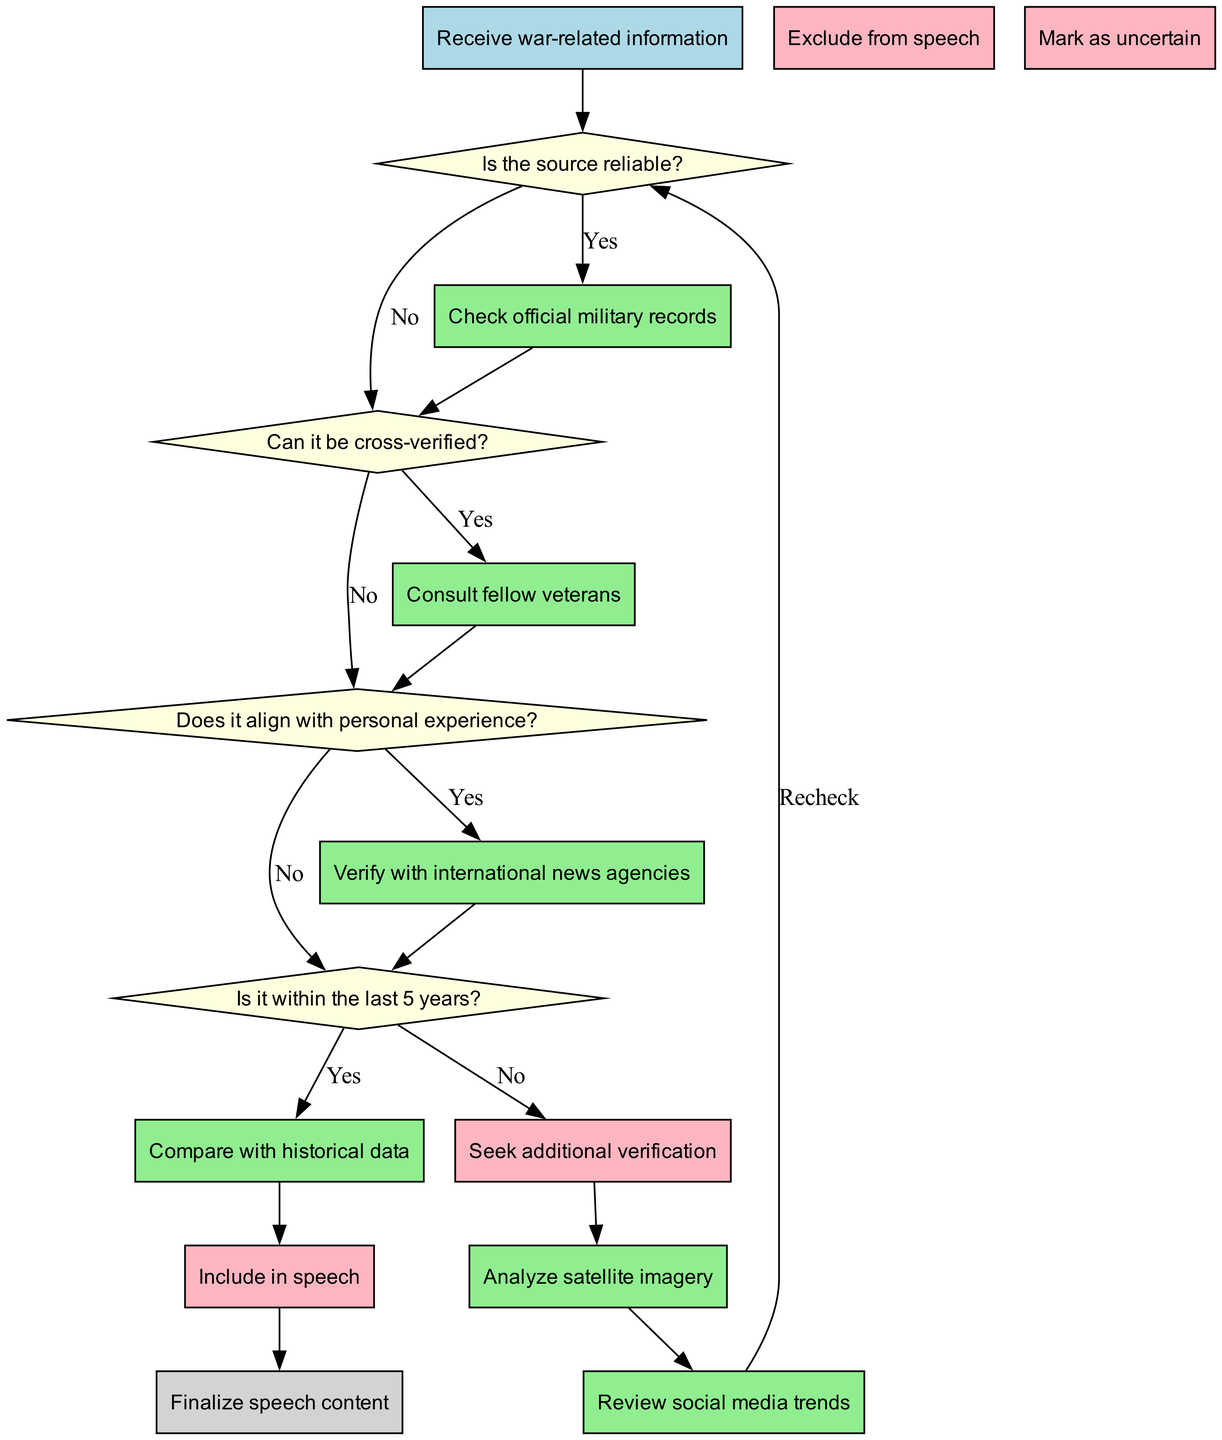What's the starting point of the flowchart? The flowchart begins with the node labeled "Receive war-related information," indicating the initial step in the process of verifying information.
Answer: Receive war-related information How many decision nodes are in the flowchart? There are four decision nodes in the flowchart, each representing a question regarding the reliability and relatability of the information.
Answer: 4 What happens if the source of the information is not reliable? If the source is not reliable, the flowchart directs the process to the next decision node, which asks if the information can be cross-verified.
Answer: Proceed to "Can it be cross-verified?" What is the first process to check if the source is reliable? The first process after confirming that the source is reliable is to "Check official military records."
Answer: Check official military records If the information can be cross-verified, which action can be taken? If the information can be cross-verified, it leads to the action of "Include in speech," indicating that the information is deemed credible and confirmed.
Answer: Include in speech What is the last node in the flowchart? The last node in the flowchart is labeled "Finalize speech content," which indicates the conclusion of the process after verifying the information.
Answer: Finalize speech content If the information does not align with personal experience, what is the next step? If the information does not align with personal experience, the process will enable the person to seek additional verification before making decisions on the inclusion of the information.
Answer: Seek additional verification What does the flowchart show about information older than five years? The flowchart indicates that if the information is older than five years, it will be marked as uncertain instead of confirmed.
Answer: Mark as uncertain What decision follows after verifying with international news agencies? After verifying with international news agencies, the flowchart proceeds to check if the information aligns with personal experience.
Answer: Check if it aligns with personal experience 